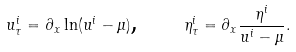<formula> <loc_0><loc_0><loc_500><loc_500>u _ { \tau } ^ { i } = \partial _ { x } \ln ( u ^ { i } - \mu ) \text {, \quad } \eta _ { \tau } ^ { i } = \partial _ { x } \frac { \eta ^ { i } } { u ^ { i } - \mu } .</formula> 